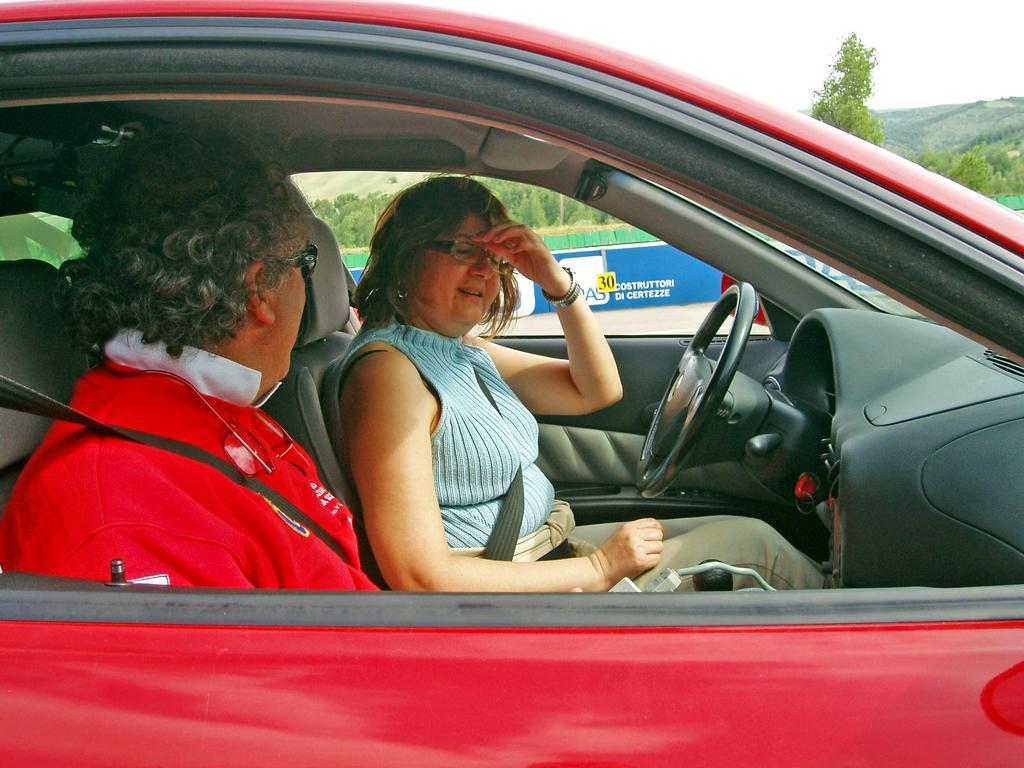Could you give a brief overview of what you see in this image? This 2 persons are sitting inside this red car. This is a steering. Far there are number of trees. 